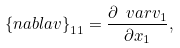Convert formula to latex. <formula><loc_0><loc_0><loc_500><loc_500>\left \{ { n a b l a } { v } \right \} _ { 1 1 } = \frac { \partial \ v a r v _ { 1 } } { \partial x _ { 1 } } ,</formula> 